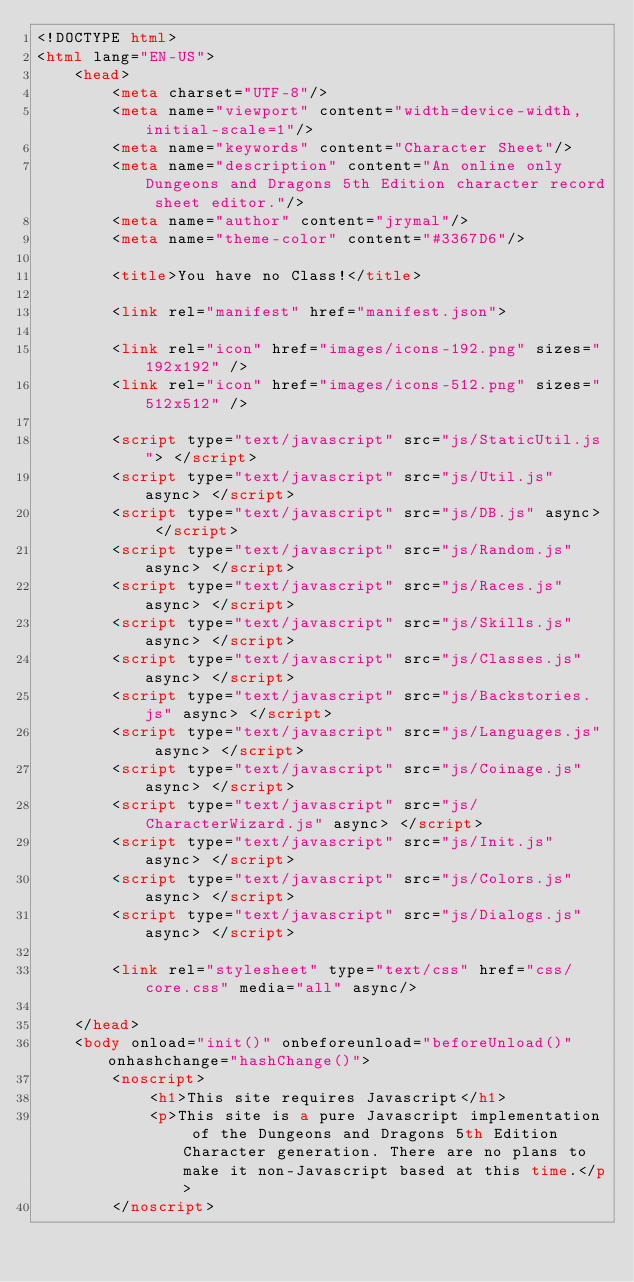<code> <loc_0><loc_0><loc_500><loc_500><_HTML_><!DOCTYPE html>
<html lang="EN-US">
    <head>
        <meta charset="UTF-8"/>
        <meta name="viewport" content="width=device-width, initial-scale=1"/>
        <meta name="keywords" content="Character Sheet"/>
        <meta name="description" content="An online only Dungeons and Dragons 5th Edition character record sheet editor."/>
        <meta name="author" content="jrymal"/>
        <meta name="theme-color" content="#3367D6"/>

        <title>You have no Class!</title>

        <link rel="manifest" href="manifest.json">

        <link rel="icon" href="images/icons-192.png" sizes="192x192" />
        <link rel="icon" href="images/icons-512.png" sizes="512x512" />

        <script type="text/javascript" src="js/StaticUtil.js"> </script>
        <script type="text/javascript" src="js/Util.js" async> </script>
        <script type="text/javascript" src="js/DB.js" async> </script>
        <script type="text/javascript" src="js/Random.js" async> </script>
        <script type="text/javascript" src="js/Races.js" async> </script>
        <script type="text/javascript" src="js/Skills.js" async> </script>
        <script type="text/javascript" src="js/Classes.js" async> </script>
        <script type="text/javascript" src="js/Backstories.js" async> </script>
        <script type="text/javascript" src="js/Languages.js" async> </script>
        <script type="text/javascript" src="js/Coinage.js" async> </script>
        <script type="text/javascript" src="js/CharacterWizard.js" async> </script>
        <script type="text/javascript" src="js/Init.js" async> </script>
        <script type="text/javascript" src="js/Colors.js" async> </script>
        <script type="text/javascript" src="js/Dialogs.js" async> </script>

        <link rel="stylesheet" type="text/css" href="css/core.css" media="all" async/>

    </head>
    <body onload="init()" onbeforeunload="beforeUnload()" onhashchange="hashChange()">
        <noscript>
            <h1>This site requires Javascript</h1>
            <p>This site is a pure Javascript implementation of the Dungeons and Dragons 5th Edition Character generation. There are no plans to make it non-Javascript based at this time.</p>
        </noscript></code> 